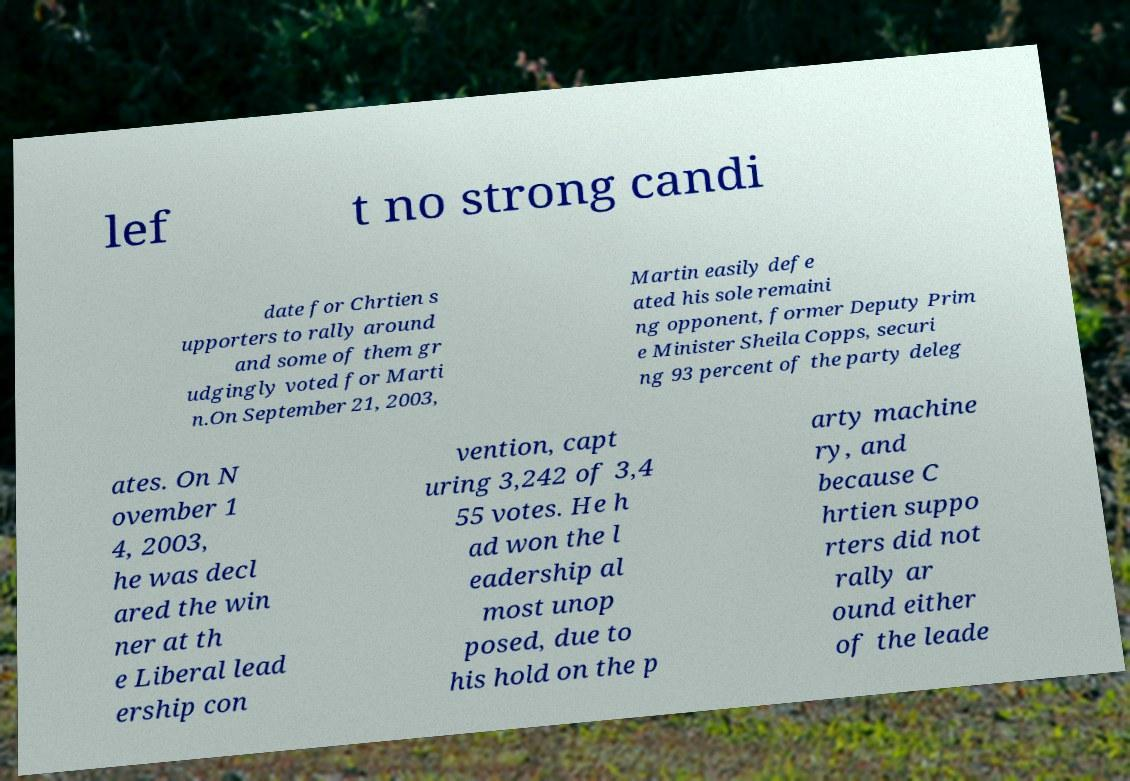Could you assist in decoding the text presented in this image and type it out clearly? lef t no strong candi date for Chrtien s upporters to rally around and some of them gr udgingly voted for Marti n.On September 21, 2003, Martin easily defe ated his sole remaini ng opponent, former Deputy Prim e Minister Sheila Copps, securi ng 93 percent of the party deleg ates. On N ovember 1 4, 2003, he was decl ared the win ner at th e Liberal lead ership con vention, capt uring 3,242 of 3,4 55 votes. He h ad won the l eadership al most unop posed, due to his hold on the p arty machine ry, and because C hrtien suppo rters did not rally ar ound either of the leade 